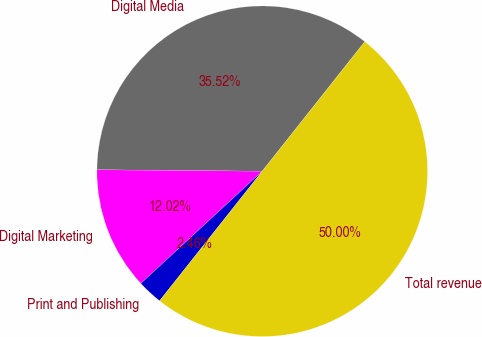<chart> <loc_0><loc_0><loc_500><loc_500><pie_chart><fcel>Digital Media<fcel>Digital Marketing<fcel>Print and Publishing<fcel>Total revenue<nl><fcel>35.52%<fcel>12.02%<fcel>2.46%<fcel>50.0%<nl></chart> 